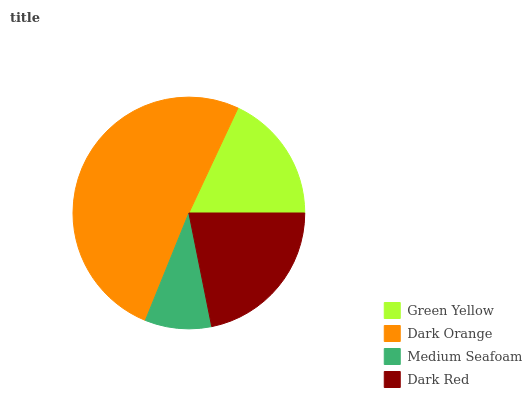Is Medium Seafoam the minimum?
Answer yes or no. Yes. Is Dark Orange the maximum?
Answer yes or no. Yes. Is Dark Orange the minimum?
Answer yes or no. No. Is Medium Seafoam the maximum?
Answer yes or no. No. Is Dark Orange greater than Medium Seafoam?
Answer yes or no. Yes. Is Medium Seafoam less than Dark Orange?
Answer yes or no. Yes. Is Medium Seafoam greater than Dark Orange?
Answer yes or no. No. Is Dark Orange less than Medium Seafoam?
Answer yes or no. No. Is Dark Red the high median?
Answer yes or no. Yes. Is Green Yellow the low median?
Answer yes or no. Yes. Is Medium Seafoam the high median?
Answer yes or no. No. Is Dark Orange the low median?
Answer yes or no. No. 